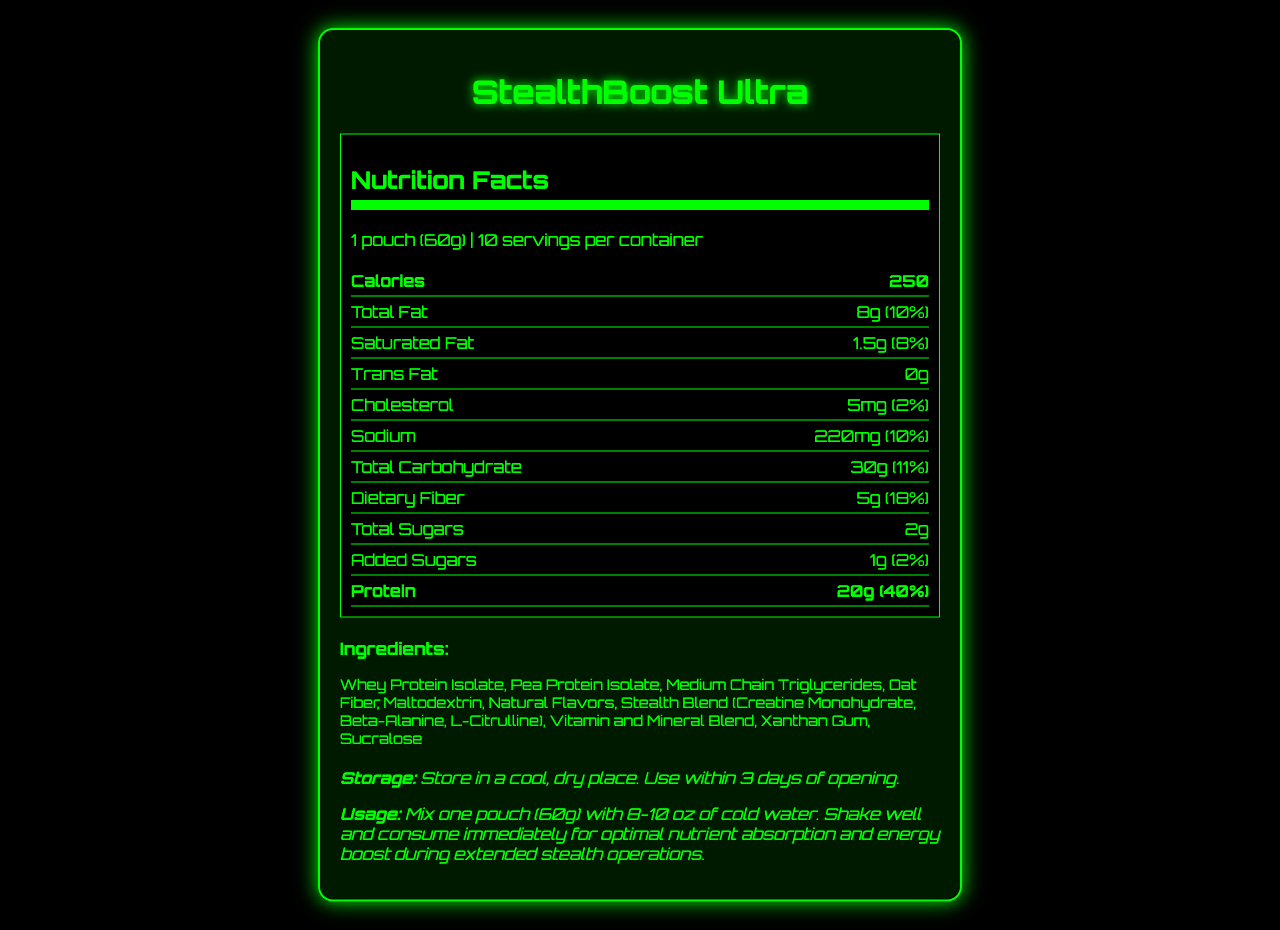what is the protein content per serving? The label clearly indicates that each serving of StealthBoost Ultra contains 20g of protein.
Answer: 20g what is the serving size for StealthBoost Ultra? The serving size is listed at the top of the nutrition label as "1 pouch (60g)".
Answer: 1 pouch (60g) how much dietary fiber is in one serving? The dietary fiber content is specified directly on the label as 5g per serving.
Answer: 5g is there any trans fat in StealthBoost Ultra? The nutrition facts label states that there are 0g of trans fat per serving.
Answer: No how much Vitamin D is in one serving? The label lists the amount of Vitamin D as 10mcg per serving.
Answer: 10mcg which of the following vitamins provides 100% of the recommended daily value per serving? A. Vitamin A B. Vitamin B6 C. Vitamin C D. Zinc Vitamin B6 provides 100% of the daily value, while Vitamin A provides 50%, Vitamin C provides 67%, and Zinc provides 50%.
Answer: B how much sodium does this product contain per serving? A. 150mg B. 200mg C. 220mg D. 250mg The label indicates that the product has 220mg of sodium per serving.
Answer: C does this product contain any added sugars? The label shows that there is 1g of added sugars per serving.
Answer: Yes is StealthBoost Ultra suitable for those with lactose intolerance? The label mentions that the product contains milk, but it doesn't specify if it is lactose-free.
Answer: I don't know summarize the key attributes of the StealthBoost Ultra nutrition label. This summary encapsulates the roles of the product as a high-protein meal replacement with a balanced nutrient profile, along with preparation and storage directions, and important allergen information.
Answer: StealthBoost Ultra is a nutrient-dense meal replacement shake designed for extended stealth operations. Each serving size is 60g with 250 calories. It has 20g of protein, 8g of fat, 30g of carbohydrates, and 5g of dietary fiber. It provides various vitamins and minerals, some at 100% of daily value, and includes ingredients like Whey Protein Isolate and Pea Protein Isolate. There are storage and usage instructions along with allergen information indicating that it contains milk and is processed in a facility handling other allergens. what additional supplements are included in the StealthBoost Ultra formula? The "Ingredients" section lists a unique blend called "Stealth Blend," which includes Creatine Monohydrate, Beta-Alanine, and L-Citrulline.
Answer: Stealth Blend (Creatine Monohydrate, Beta-Alanine, L-Citrulline) does the StealthBoost Ultra contain iron? One serving of StealthBoost Ultra contains 4.5mg of iron, which is 25% of the daily value.
Answer: Yes how long can you store StealthBoost Ultra after opening? The storage instructions indicate that the product should be used within 3 days of opening.
Answer: 3 days what is the recommended amount of water to mix with one pouch? The usage instructions recommend mixing one pouch with 8-10 oz of cold water.
Answer: 8-10 oz 